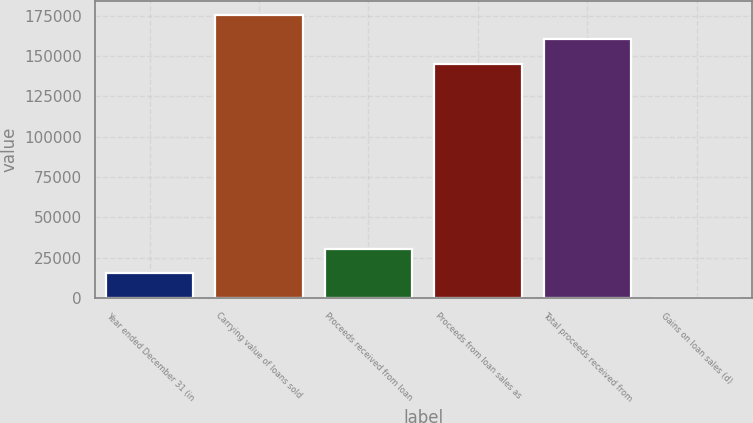Convert chart. <chart><loc_0><loc_0><loc_500><loc_500><bar_chart><fcel>Year ended December 31 (in<fcel>Carrying value of loans sold<fcel>Proceeds received from loan<fcel>Proceeds from loan sales as<fcel>Total proceeds received from<fcel>Gains on loan sales (d)<nl><fcel>15182.9<fcel>175440<fcel>30232.8<fcel>145340<fcel>160390<fcel>133<nl></chart> 